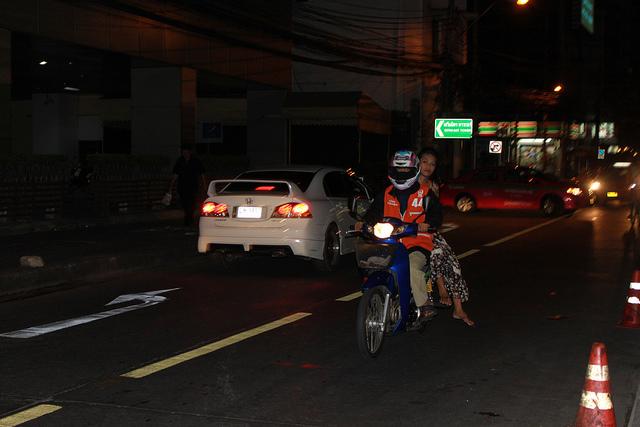What direction is the arrow pointing in the road?
Answer briefly. Left. Are both people on the motorcycle wearing helmets?
Write a very short answer. No. What color is the car on the left?
Quick response, please. White. What is the tail light of the automobile leaving a trail?
Keep it brief. Red. 